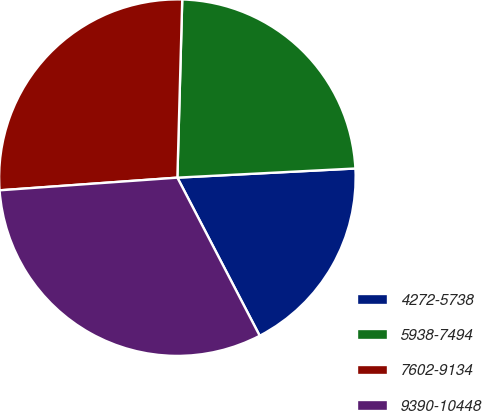Convert chart. <chart><loc_0><loc_0><loc_500><loc_500><pie_chart><fcel>4272-5738<fcel>5938-7494<fcel>7602-9134<fcel>9390-10448<nl><fcel>18.18%<fcel>23.75%<fcel>26.57%<fcel>31.51%<nl></chart> 